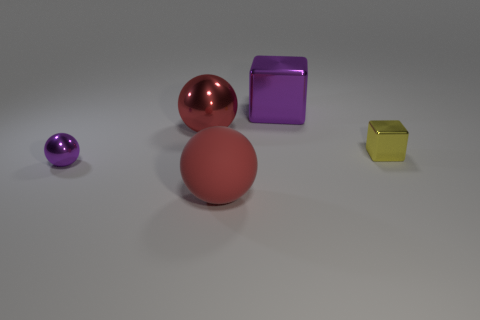Can you describe the objects' colors and shapes in the image? Certainly! The image features four objects. Starting from the left, there's a small purple ball, a larger matte red ball, a big red shiny sphere, and finally a small yellow cube. The small purple object is a sphere, the large red object in the center has a matte finish and is also spherical, the red shiny object to the right is a larger sphere with a reflective surface, and the yellow object is a cube with a slightly transparent appearance. 